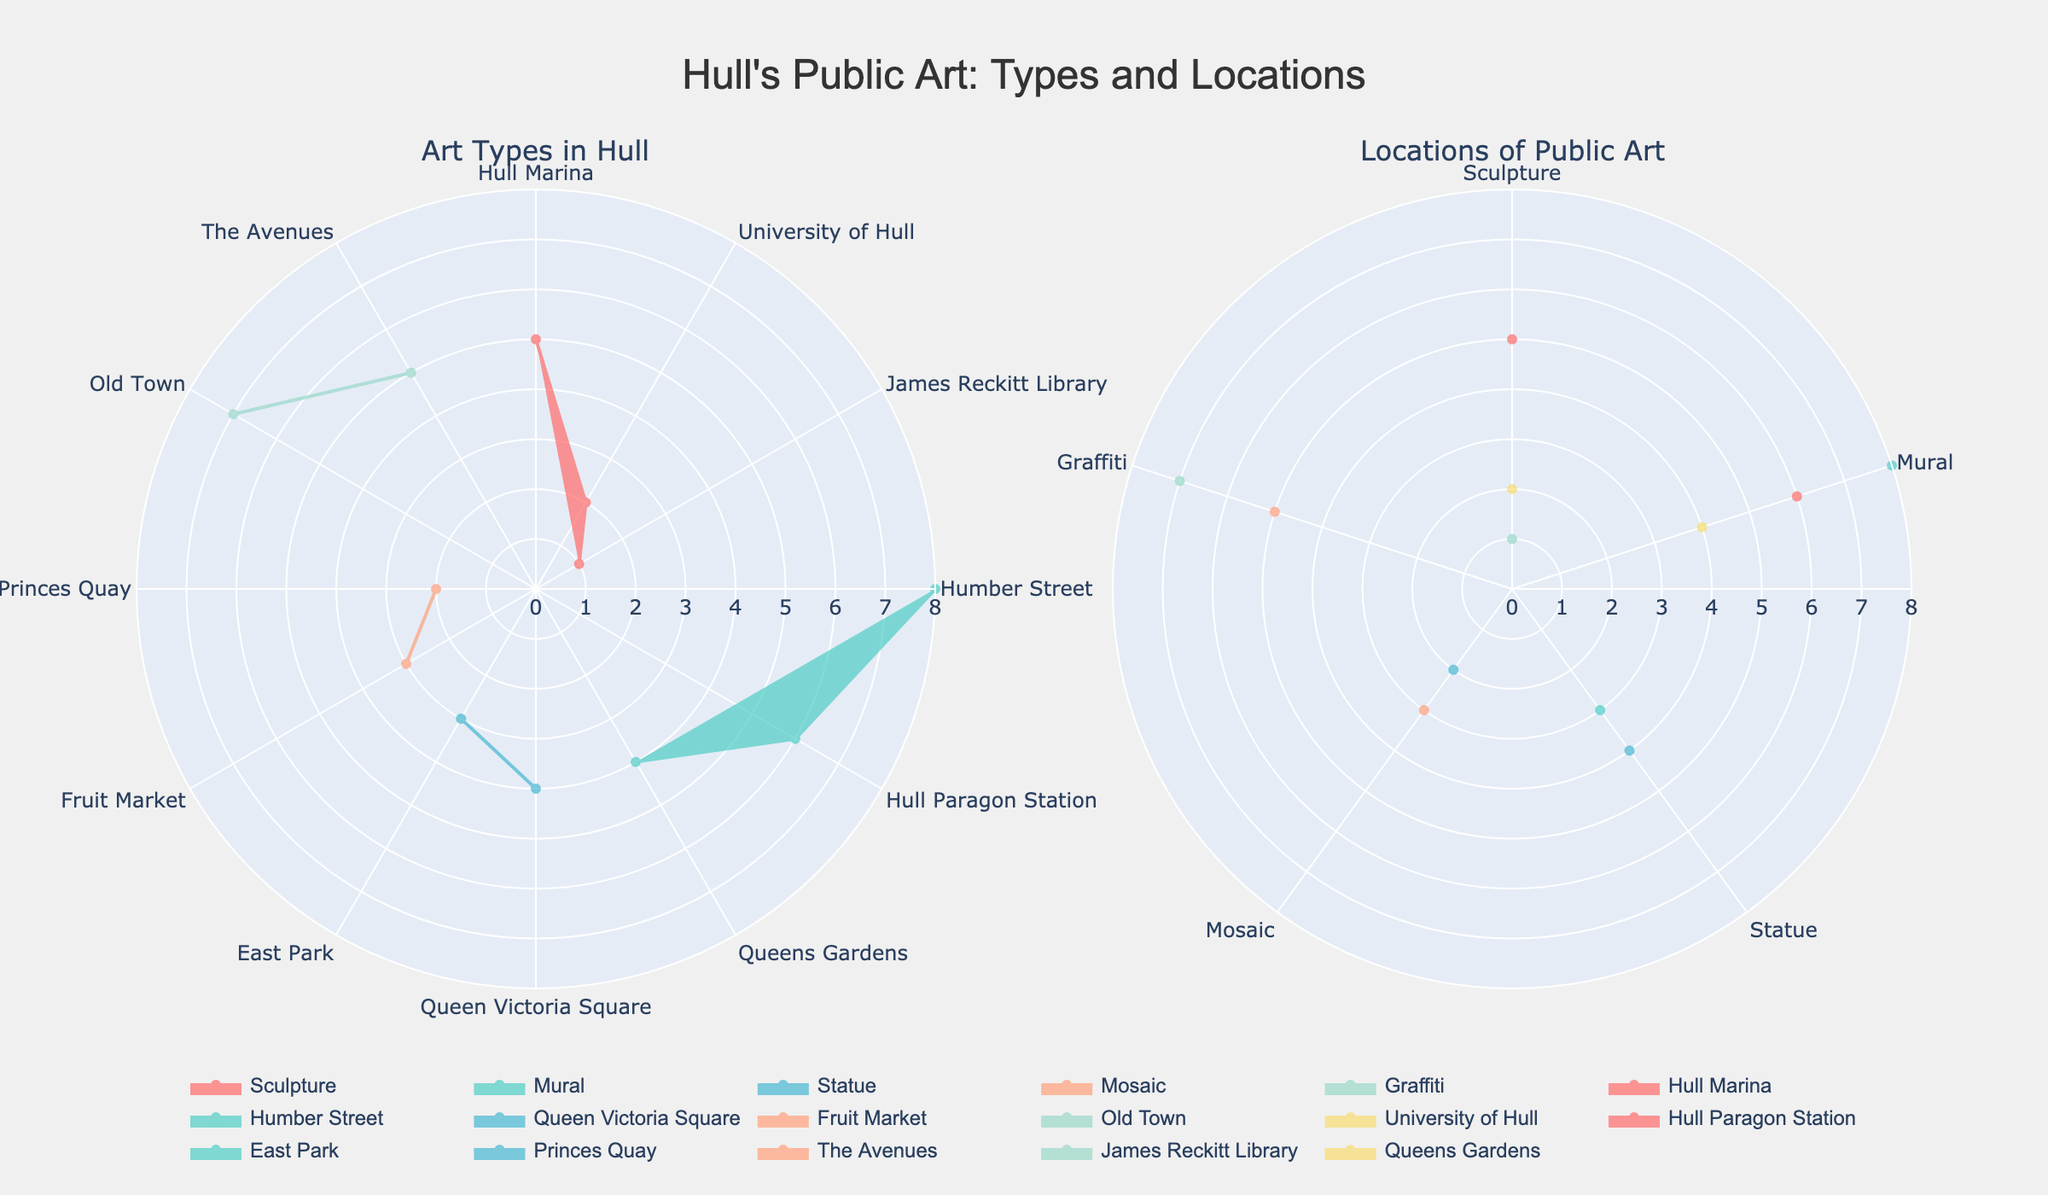What's the title of the figure? The title is located at the top of the figure. It provides a summary of what the figure represents. Upon examining the top of the figure, we see the title "Hull's Public Art: Types and Locations."
Answer: Hull's Public Art: Types and Locations Which art type has the highest count in Hull Marina? From the subplot titled "Art Types in Hull", we locate Hull Marina on the polar chart. The corresponding art type with the largest range from the center represents the highest count. Here, it is the sculpture with a count of 5.
Answer: Sculpture What are the locations with the highest count of murals? By looking at the "Art Types in Hull" subplot for mural data, we examine which locations have the highest radial values. Humber Street shows 8 murals while Hull Paragon Station has 6 murals, indicating these are the locations with the highest count of murals.
Answer: Humber Street, Hull Paragon Station How many total public art installations are there at Fruit Market? We use the "Locations of Public Art" subplot and find the radial values for Fruit Market. The count is represented by the radial distance. For mosaics, the count is 3. Since it's the only art type in Fruit Market, the total count is 3.
Answer: 3 Which location has more graffiti, Old Town or The Avenues? In the "Locations of Public Art" subplot, we locate both Old Town and The Avenues and compare the radial values. Old Town has a radial value of 7 for graffiti, while The Avenues has a radial value of 5. Therefore, Old Town has more graffiti.
Answer: Old Town What is the combined count of sculptures and statues in Queen Victoria Square? From the "Art Types in Hull" subplot, we locate Queen Victoria Square and add the counts for sculptures and statues. Sculptures in Queen Victoria Square have a count of 0, but statues have a count of 4. The combined total is 0 + 4 = 4.
Answer: 4 Which art type is most common in Hull Paragon Station? Refer to the "Locations of Public Art" subplot and locate Hull Paragon Station. The one with the longest radial line is the most common. Murals, with 6 counts, have the longest radial line in Hull Paragon Station, indicating it's the most common art type there.
Answer: Mural In which location can one find the most diverse types of public art installations? Diversity is measured by the number of different art types. Examine the "Locations of Public Art" subplot. Count the radial segments for each location. Humber Street shows 3 different types: Mural, Graffiti, and Mosaic. No other location displays more types.
Answer: Humber Street Which art type has the least amount of public installations overall? For an overall comparison, we look at the "Art Types in Hull" subplot and compare the total radial lengths for each art type. Mosaics, with their smaller lengths, indicate the least count of public installations across all locations.
Answer: Mosaic 